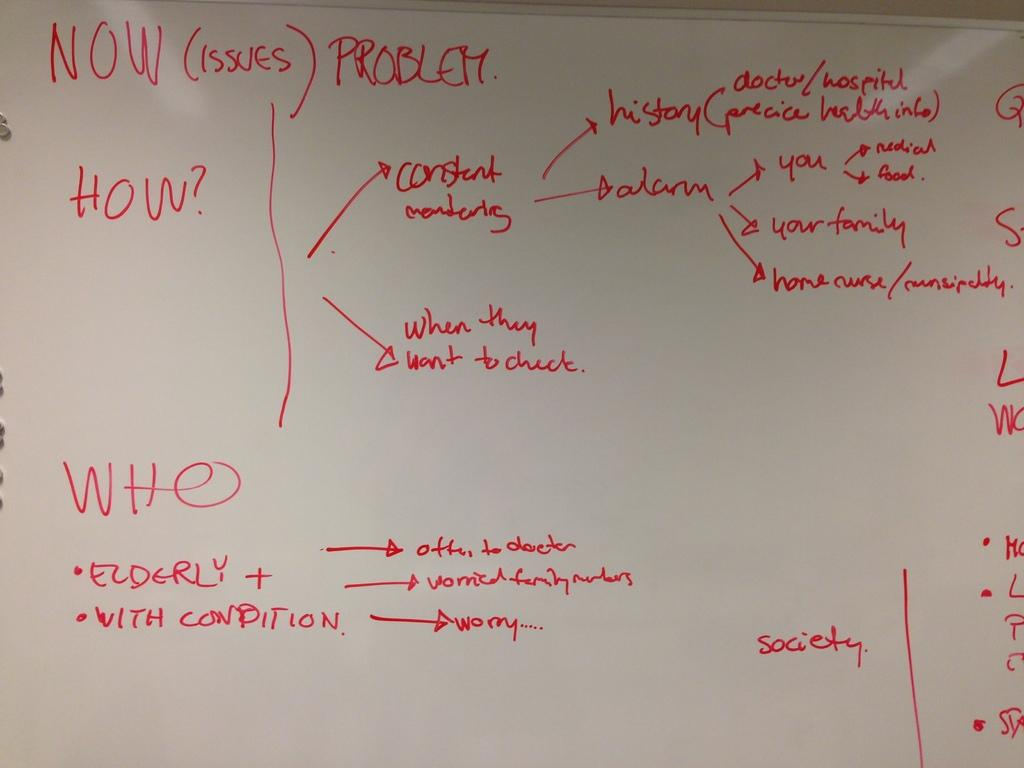<image>
Give a short and clear explanation of the subsequent image. A white board with writing that says Now (issues) Problems and says how and who on it with explanations. 